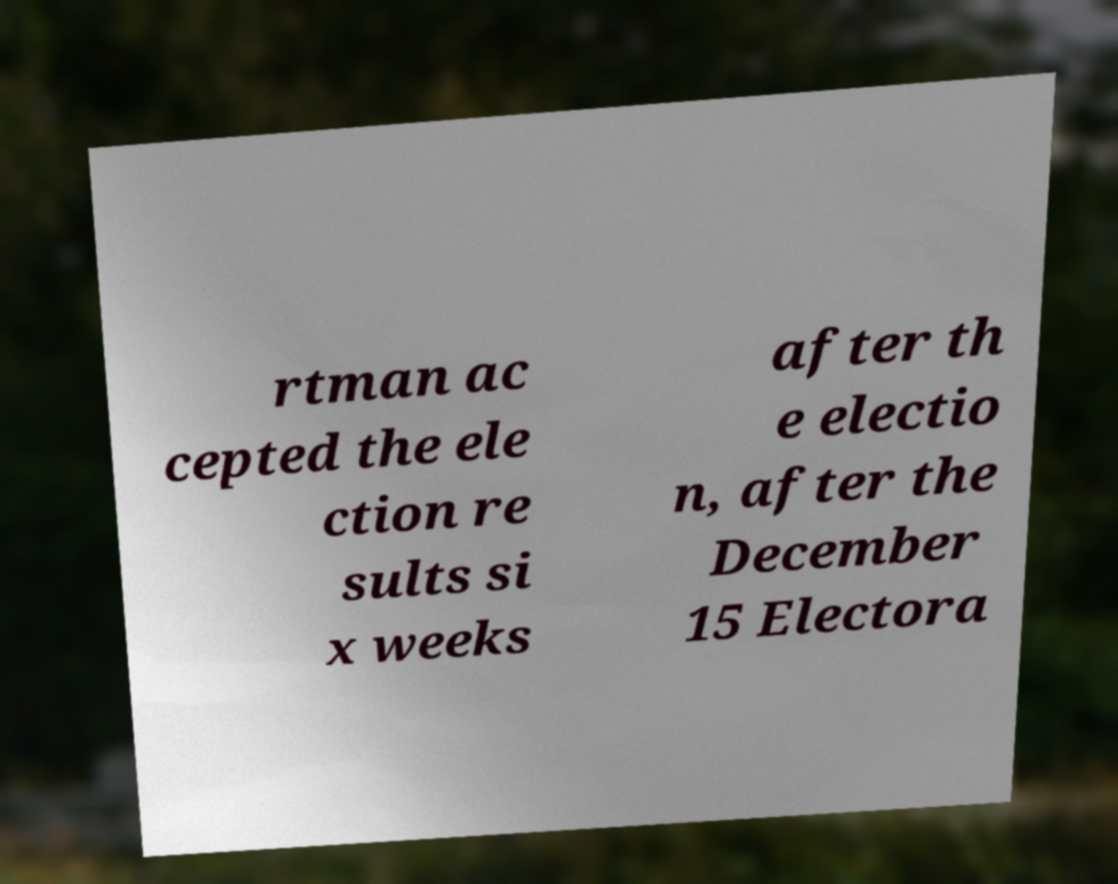Can you accurately transcribe the text from the provided image for me? rtman ac cepted the ele ction re sults si x weeks after th e electio n, after the December 15 Electora 